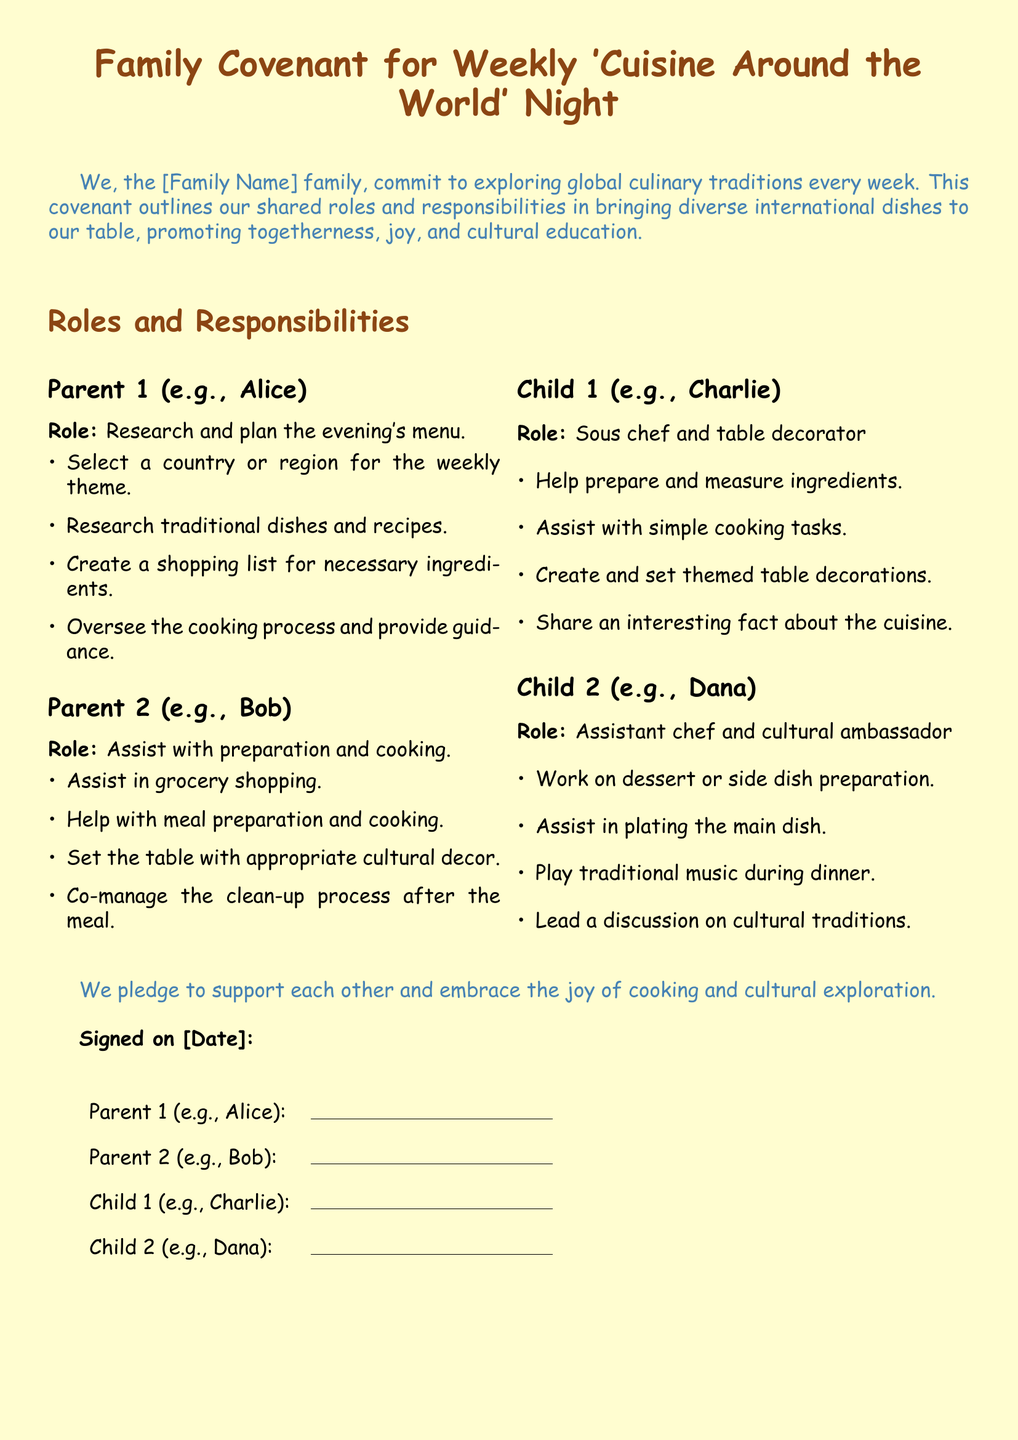What is the title of the document? The title is presented at the beginning of the document, highlighting the family's commitment to a specific culinary theme.
Answer: Family Covenant for Weekly 'Cuisine Around the World' Night Who is responsible for researching the evening's menu? The document assigns specific roles to family members, with one person designated to research and plan.
Answer: Parent 1 (e.g., Alice) Which child works on dessert or side dish preparation? The roles detail which family member is assigned to specific tasks, including dessert preparation.
Answer: Child 2 (e.g., Dana) What is the pledge stated in the document? The document contains a commitment that reflects the family's shared values and goals for their gathering.
Answer: to support each other and embrace the joy of cooking and cultural exploration What is one responsibility of Parent 2? This question highlights the actions Parent 2 must take during the themed dinner preparations, as listed.
Answer: Assist with preparation and cooking How many family members' roles are detailed in the document? The document outlines roles for each family member involved in the themed night, illustrating family participation.
Answer: Four What is one task assigned to Child 1? Each child's role includes specific tasks, demonstrating their involvement and contributions to the event.
Answer: Help prepare and measure ingredients What type of music is played during dinner? The document identifies particular activities including entertainment that occur during the themed night.
Answer: traditional music 